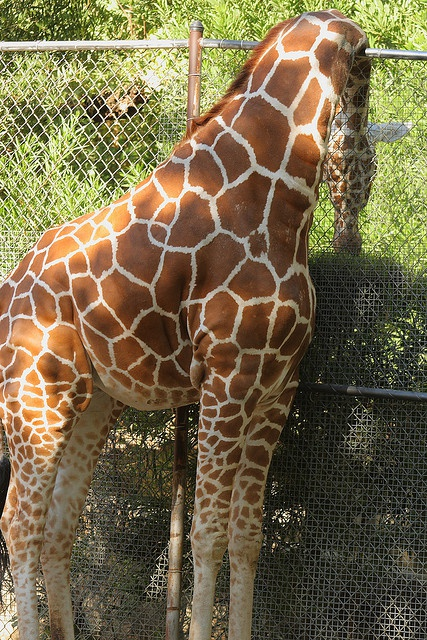Describe the objects in this image and their specific colors. I can see a giraffe in olive, maroon, and gray tones in this image. 